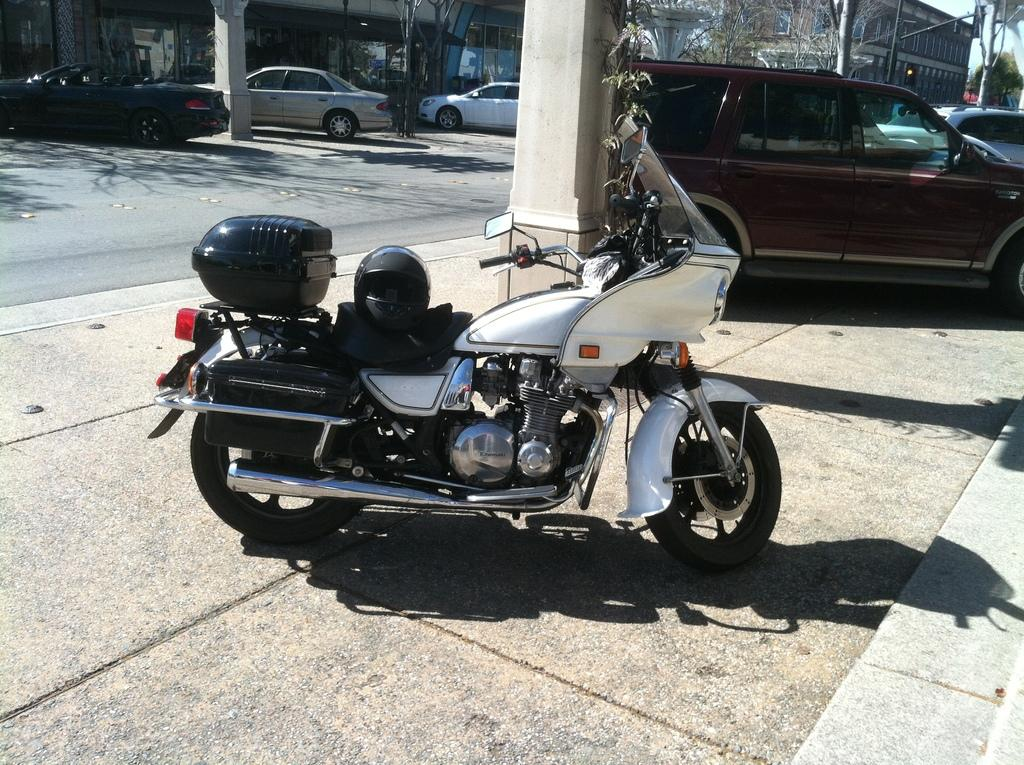What can be seen parked in the image? There are vehicles parked in the image. Where are the vehicles parked in relation to the road? The vehicles are parked to the side of the road. What type of natural elements are visible in the image? There are trees visible in the image. What type of man-made structures can be seen in the image? There are buildings in the image. Can you see a person's lips in the image? There is no person or lips visible in the image. What type of mist is covering the vehicles in the image? There is no mist present in the image; the vehicles are parked on a clear road. 